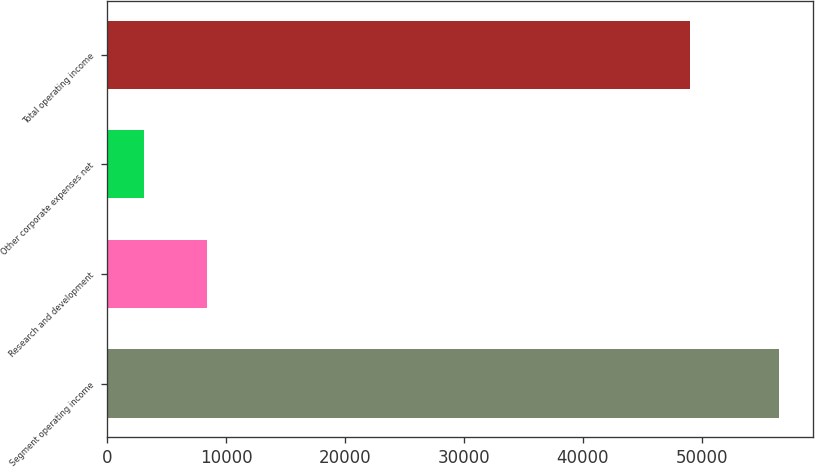Convert chart to OTSL. <chart><loc_0><loc_0><loc_500><loc_500><bar_chart><fcel>Segment operating income<fcel>Research and development<fcel>Other corporate expenses net<fcel>Total operating income<nl><fcel>56525<fcel>8398.4<fcel>3051<fcel>48999<nl></chart> 